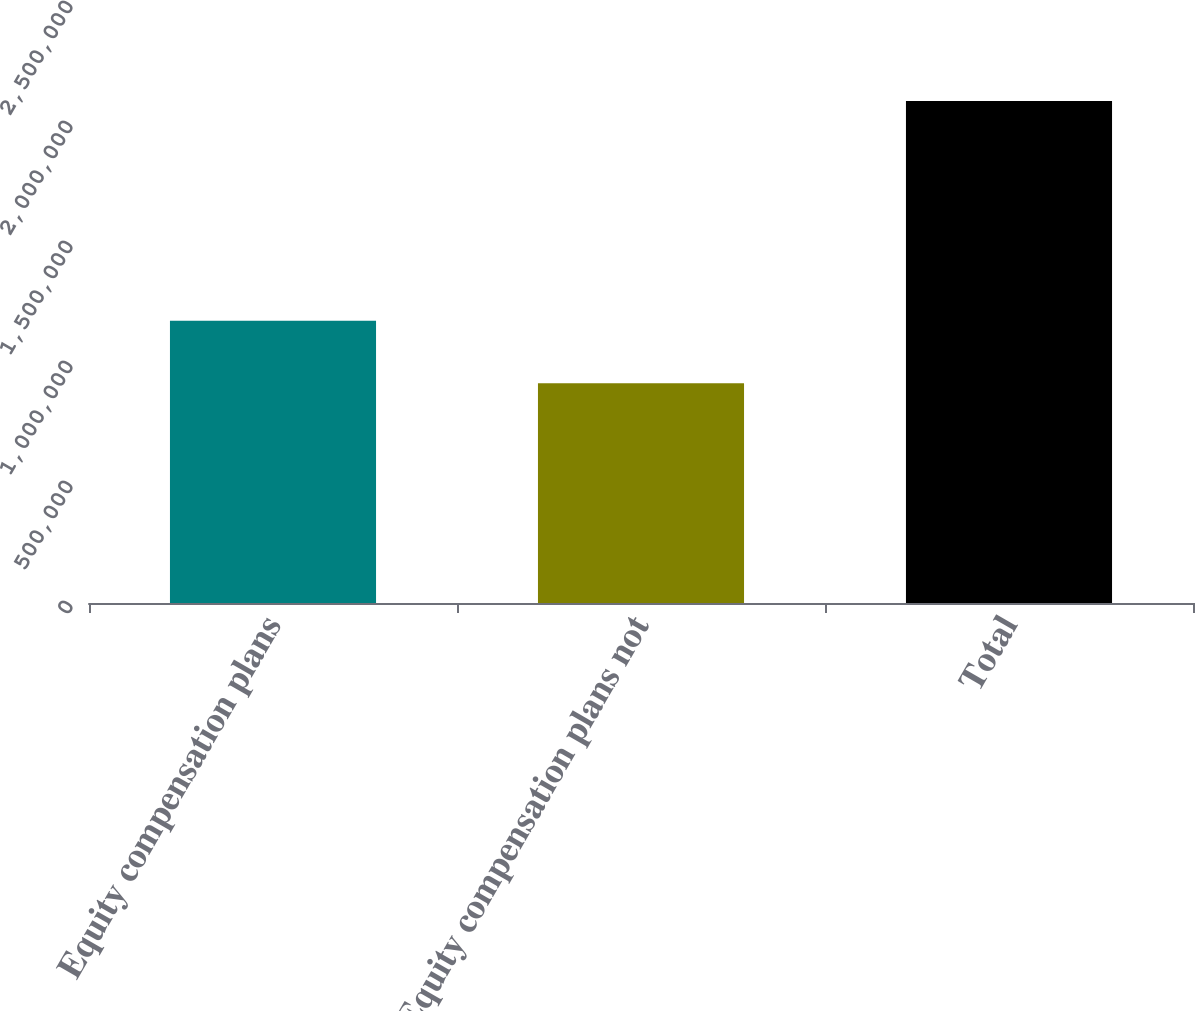<chart> <loc_0><loc_0><loc_500><loc_500><bar_chart><fcel>Equity compensation plans<fcel>Equity compensation plans not<fcel>Total<nl><fcel>1.17568e+06<fcel>915540<fcel>2.09122e+06<nl></chart> 